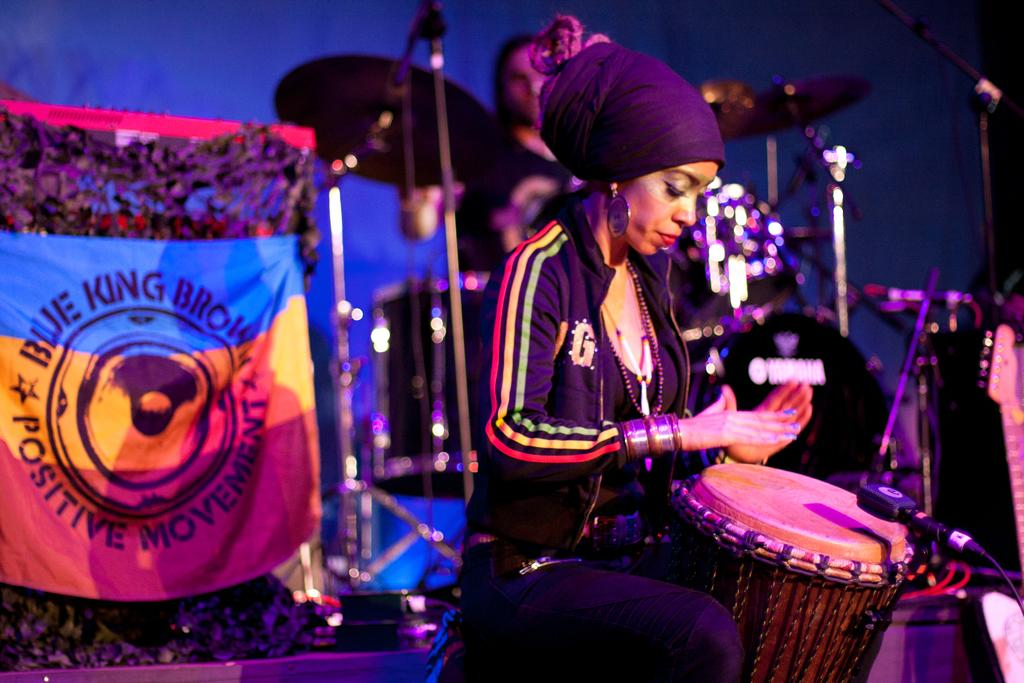Who is the main subject in the image? There is a woman in the image. What is the woman doing in the image? The woman is playing drums. Where is the woman located in the image? The woman is on a dais. What type of fish can be seen swimming near the woman in the image? There are no fish present in the image; it features a woman playing drums on a dais. What does the image smell like? The image is a visual representation and does not have a smell. 